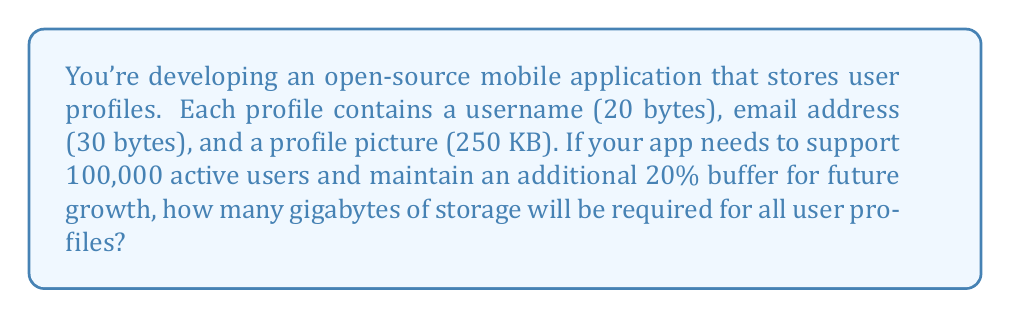Give your solution to this math problem. Let's break this down step-by-step:

1) First, calculate the total size of one user profile:
   - Username: 20 bytes
   - Email: 30 bytes
   - Profile picture: 250 KB = 250 * 1024 bytes = 256,000 bytes
   Total: $20 + 30 + 256000 = 256050$ bytes

2) Calculate the number of users including the 20% buffer:
   $100000 * 1.2 = 120000$ users

3) Calculate the total storage needed in bytes:
   $256050 * 120000 = 30726000000$ bytes

4) Convert bytes to gigabytes:
   $30726000000 / (1024^3) \approx 28.61$ GB

Therefore, the storage requirement for all user profiles, including the buffer, is approximately 28.61 GB.
Answer: 28.61 GB 